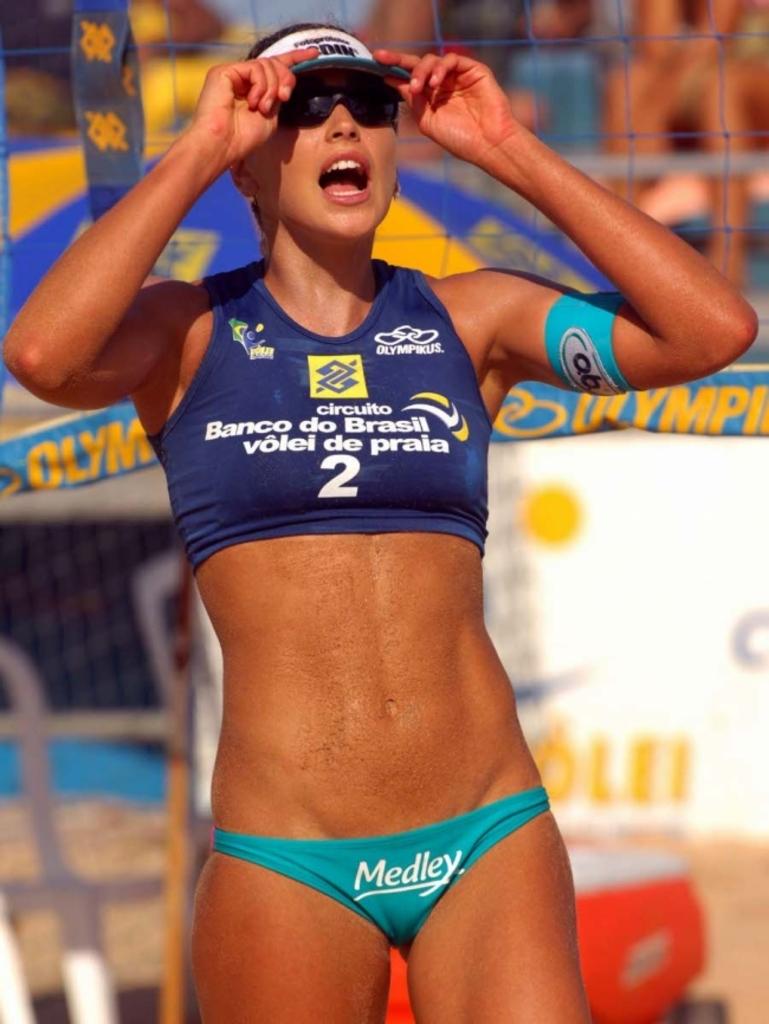What is on the arm band of this player?
Give a very brief answer. Ob. What number is this lady?
Your response must be concise. 2. 